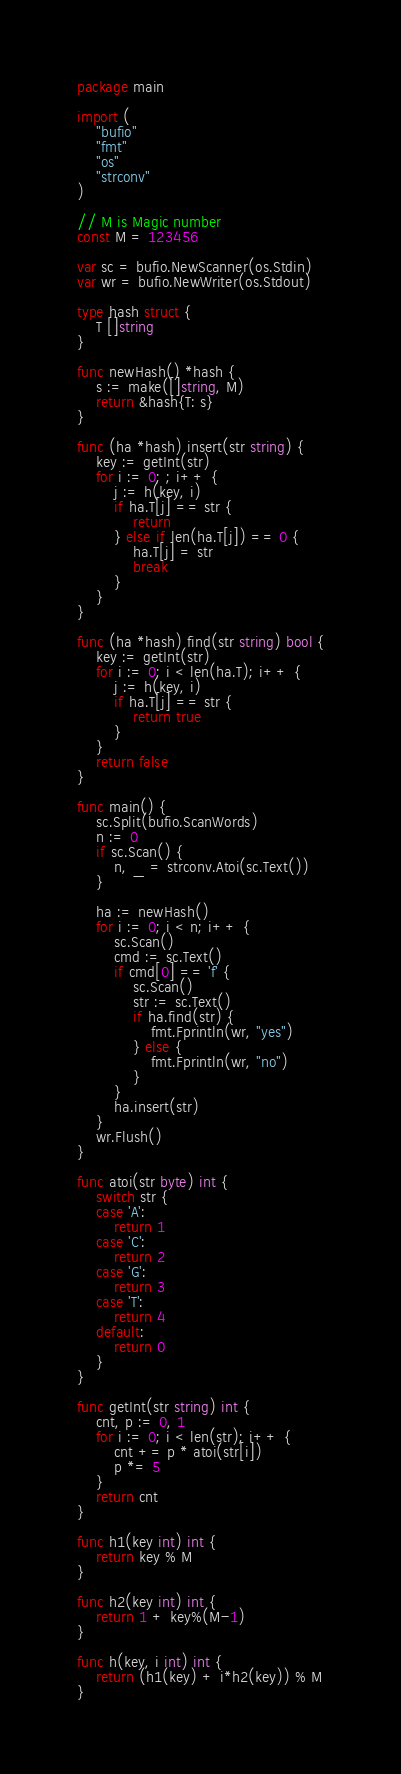<code> <loc_0><loc_0><loc_500><loc_500><_Go_>package main

import (
	"bufio"
	"fmt"
	"os"
	"strconv"
)

// M is Magic number
const M = 123456

var sc = bufio.NewScanner(os.Stdin)
var wr = bufio.NewWriter(os.Stdout)

type hash struct {
	T []string
}

func newHash() *hash {
	s := make([]string, M)
	return &hash{T: s}
}

func (ha *hash) insert(str string) {
	key := getInt(str)
	for i := 0; ; i++ {
		j := h(key, i)
		if ha.T[j] == str {
			return
		} else if len(ha.T[j]) == 0 {
			ha.T[j] = str
			break
		}
	}
}

func (ha *hash) find(str string) bool {
	key := getInt(str)
	for i := 0; i < len(ha.T); i++ {
		j := h(key, i)
		if ha.T[j] == str {
			return true
		}
	}
	return false
}

func main() {
	sc.Split(bufio.ScanWords)
	n := 0
	if sc.Scan() {
		n, _ = strconv.Atoi(sc.Text())
	}

	ha := newHash()
	for i := 0; i < n; i++ {
		sc.Scan()
		cmd := sc.Text()
		if cmd[0] == 'f' {
			sc.Scan()
			str := sc.Text()
			if ha.find(str) {
				fmt.Fprintln(wr, "yes")
			} else {
				fmt.Fprintln(wr, "no")
			}
		}
		ha.insert(str)
	}
	wr.Flush()
}

func atoi(str byte) int {
	switch str {
	case 'A':
		return 1
	case 'C':
		return 2
	case 'G':
		return 3
	case 'T':
		return 4
	default:
		return 0
	}
}

func getInt(str string) int {
	cnt, p := 0, 1
	for i := 0; i < len(str); i++ {
		cnt += p * atoi(str[i])
		p *= 5
	}
	return cnt
}

func h1(key int) int {
	return key % M
}

func h2(key int) int {
	return 1 + key%(M-1)
}

func h(key, i int) int {
	return (h1(key) + i*h2(key)) % M
}

</code> 